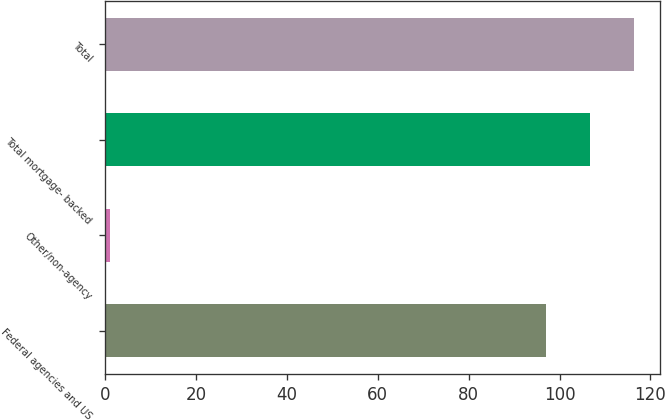Convert chart. <chart><loc_0><loc_0><loc_500><loc_500><bar_chart><fcel>Federal agencies and US<fcel>Other/non-agency<fcel>Total mortgage- backed<fcel>Total<nl><fcel>97<fcel>1<fcel>106.7<fcel>116.4<nl></chart> 